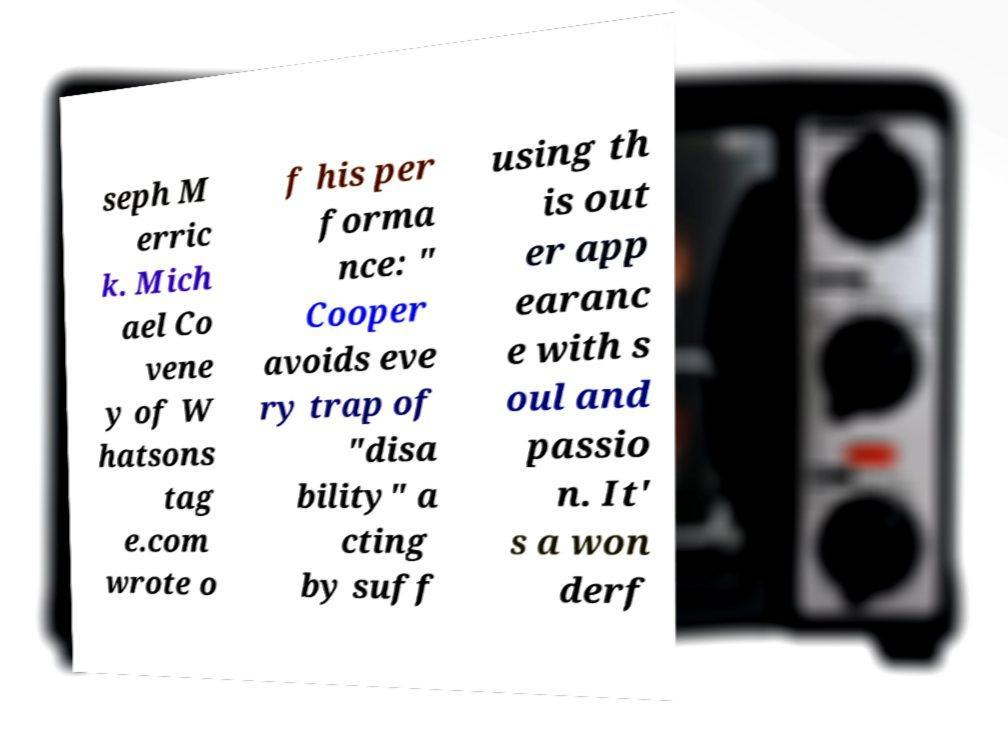Can you accurately transcribe the text from the provided image for me? seph M erric k. Mich ael Co vene y of W hatsons tag e.com wrote o f his per forma nce: " Cooper avoids eve ry trap of "disa bility" a cting by suff using th is out er app earanc e with s oul and passio n. It' s a won derf 